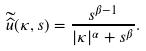Convert formula to latex. <formula><loc_0><loc_0><loc_500><loc_500>\widetilde { \widehat { u } } ( \kappa , s ) = \frac { s ^ { \beta - 1 } } { | \kappa | ^ { \alpha } + s ^ { \beta } } .</formula> 